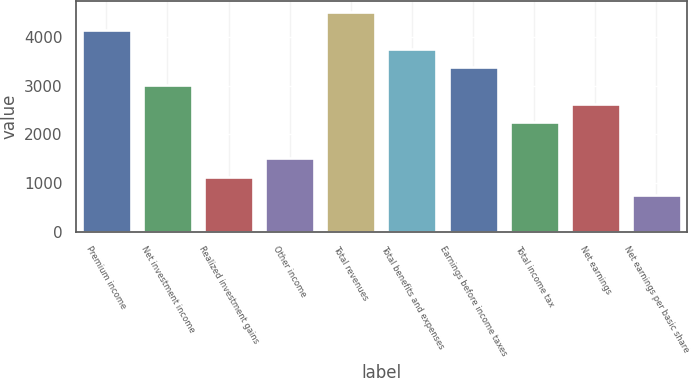Convert chart. <chart><loc_0><loc_0><loc_500><loc_500><bar_chart><fcel>Premium income<fcel>Net investment income<fcel>Realized investment gains<fcel>Other income<fcel>Total revenues<fcel>Total benefits and expenses<fcel>Earnings before income taxes<fcel>Total income tax<fcel>Net earnings<fcel>Net earnings per basic share<nl><fcel>4140.38<fcel>3011.24<fcel>1129.34<fcel>1505.72<fcel>4516.76<fcel>3764<fcel>3387.62<fcel>2258.48<fcel>2634.86<fcel>752.96<nl></chart> 